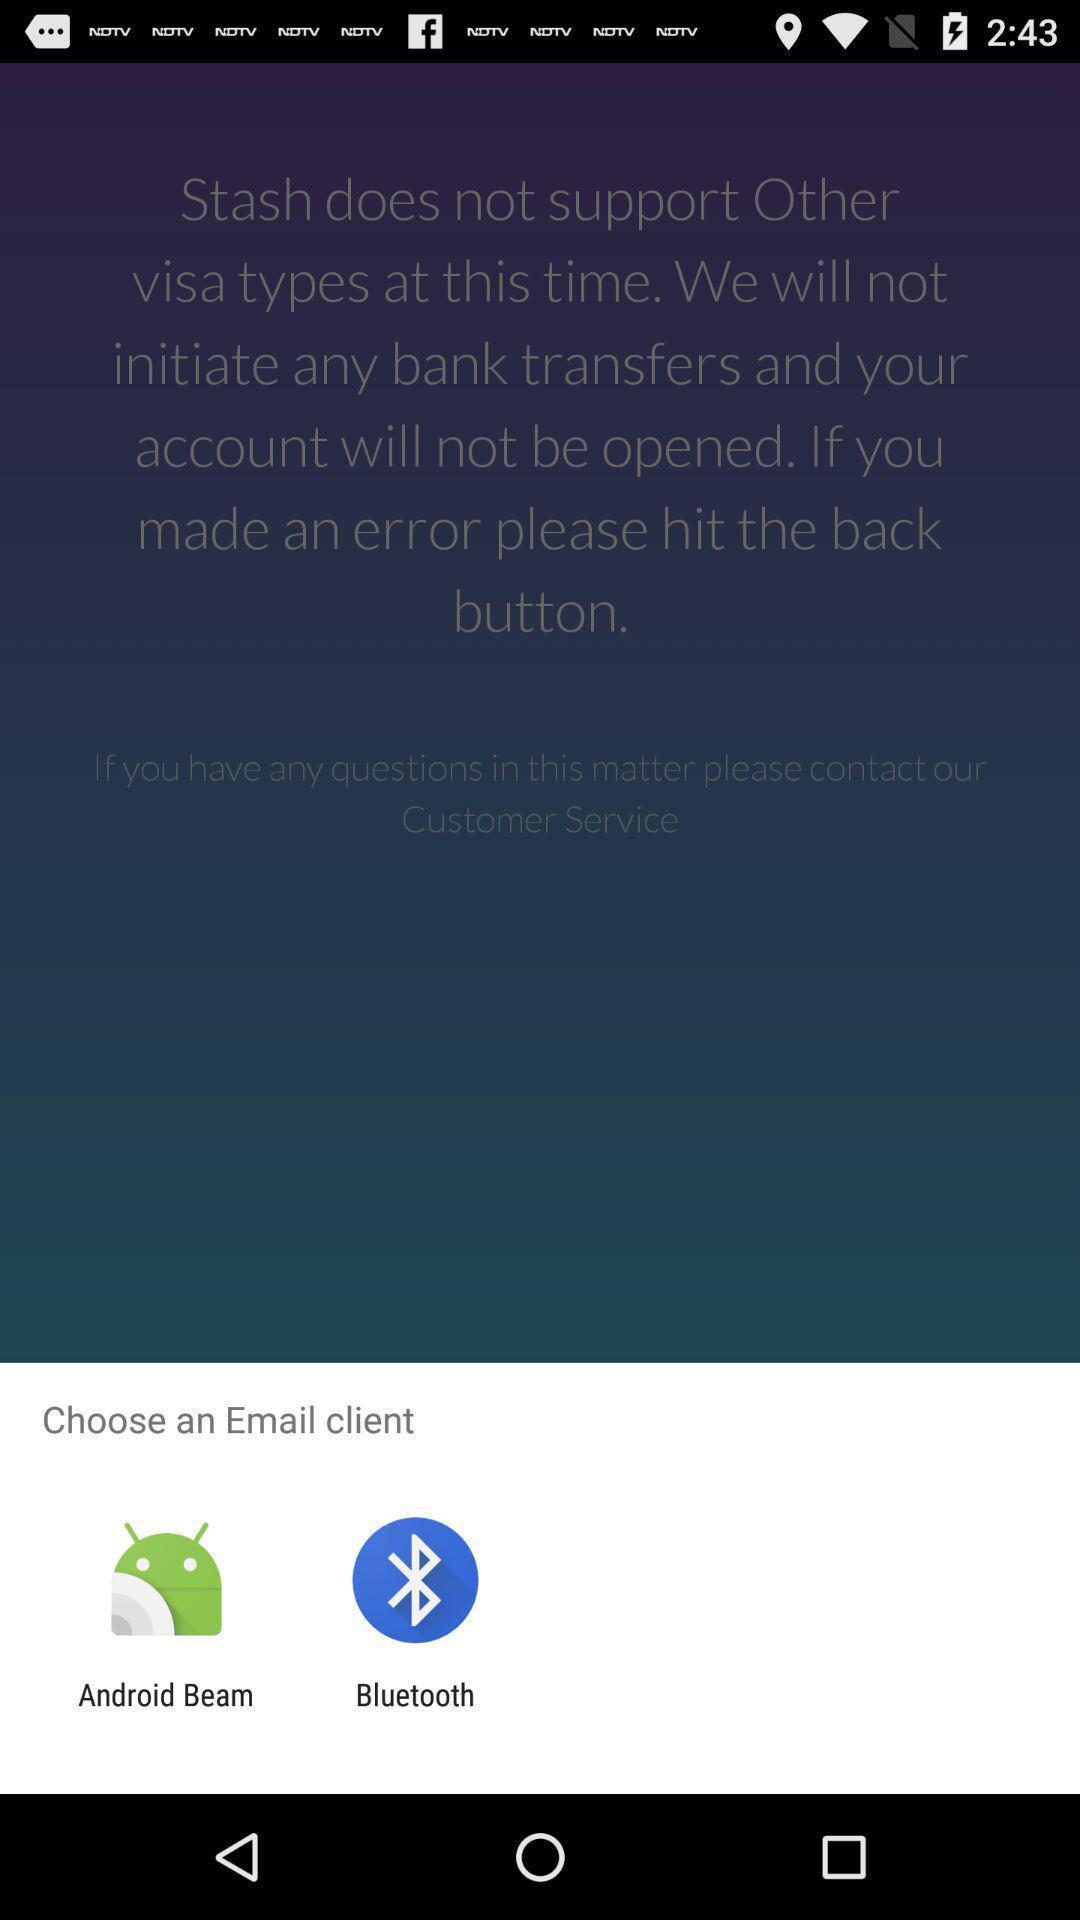Describe the visual elements of this screenshot. Popup displaying applications to open an email client in app. 